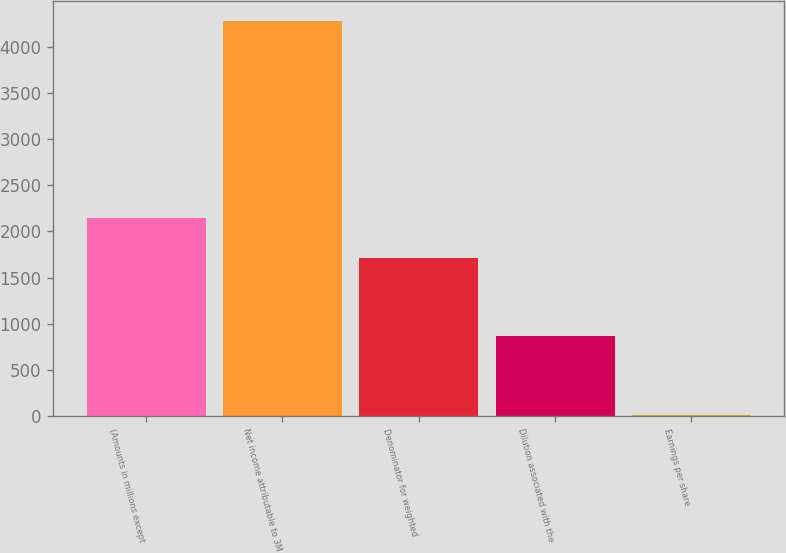<chart> <loc_0><loc_0><loc_500><loc_500><bar_chart><fcel>(Amounts in millions except<fcel>Net income attributable to 3M<fcel>Denominator for weighted<fcel>Dilution associated with the<fcel>Earnings per share<nl><fcel>2144.46<fcel>4283<fcel>1716.76<fcel>861.36<fcel>5.96<nl></chart> 